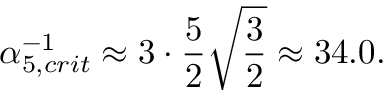Convert formula to latex. <formula><loc_0><loc_0><loc_500><loc_500>\alpha _ { 5 , c r i t } ^ { - 1 } \approx 3 \cdot \frac { 5 } { 2 } \sqrt { \frac { 3 } { 2 } } \approx 3 4 . 0 .</formula> 